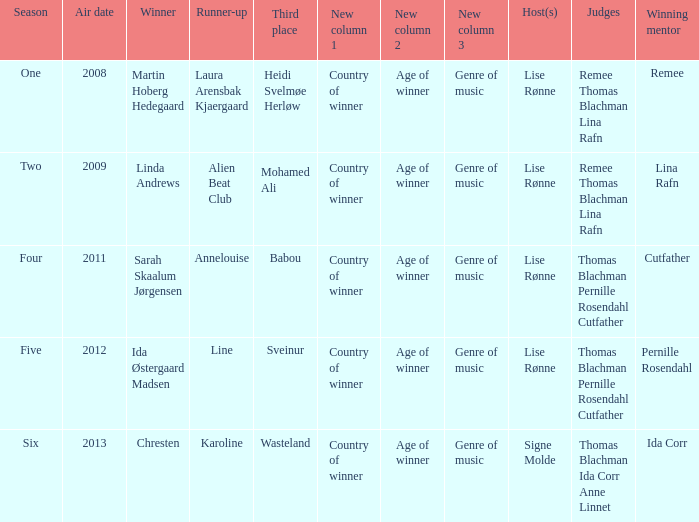Who was the winning mentor in season two? Lina Rafn. Give me the full table as a dictionary. {'header': ['Season', 'Air date', 'Winner', 'Runner-up', 'Third place', 'New column 1', 'New column 2', 'New column 3', 'Host(s)', 'Judges', 'Winning mentor'], 'rows': [['One', '2008', 'Martin Hoberg Hedegaard', 'Laura Arensbak Kjaergaard', 'Heidi Svelmøe Herløw', 'Country of winner', 'Age of winner', 'Genre of music', 'Lise Rønne', 'Remee Thomas Blachman Lina Rafn', 'Remee'], ['Two', '2009', 'Linda Andrews', 'Alien Beat Club', 'Mohamed Ali', 'Country of winner', 'Age of winner', 'Genre of music', 'Lise Rønne', 'Remee Thomas Blachman Lina Rafn', 'Lina Rafn'], ['Four', '2011', 'Sarah Skaalum Jørgensen', 'Annelouise', 'Babou', 'Country of winner', 'Age of winner', 'Genre of music', 'Lise Rønne', 'Thomas Blachman Pernille Rosendahl Cutfather', 'Cutfather'], ['Five', '2012', 'Ida Østergaard Madsen', 'Line', 'Sveinur', 'Country of winner', 'Age of winner', 'Genre of music', 'Lise Rønne', 'Thomas Blachman Pernille Rosendahl Cutfather', 'Pernille Rosendahl'], ['Six', '2013', 'Chresten', 'Karoline', 'Wasteland', 'Country of winner', 'Age of winner', 'Genre of music', 'Signe Molde', 'Thomas Blachman Ida Corr Anne Linnet', 'Ida Corr']]} 